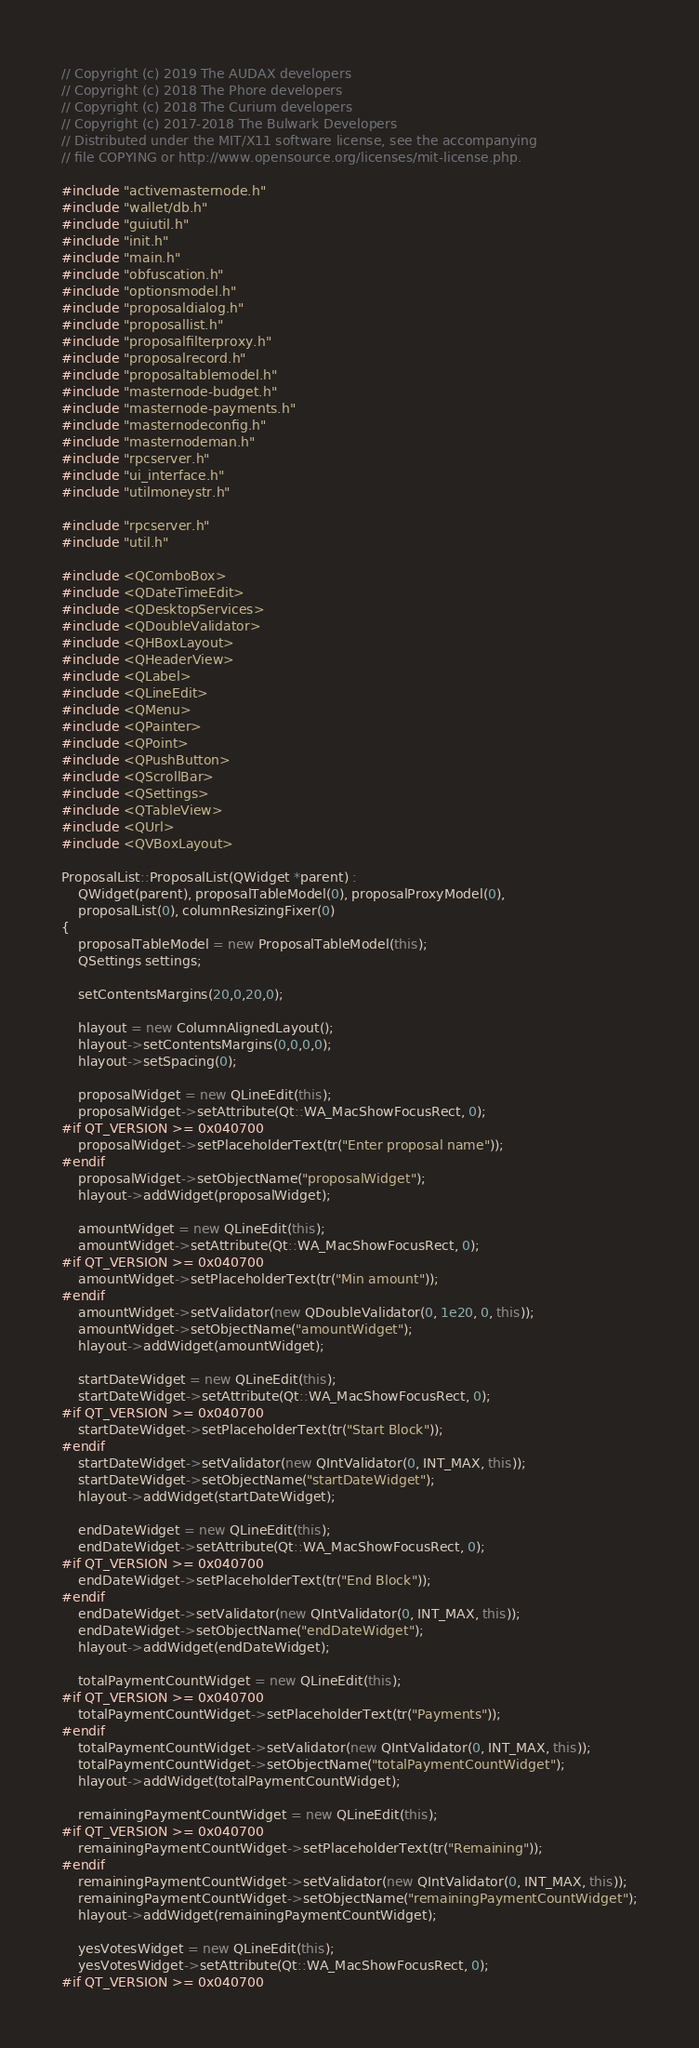<code> <loc_0><loc_0><loc_500><loc_500><_C++_>// Copyright (c) 2019 The AUDAX developers
// Copyright (c) 2018 The Phore developers
// Copyright (c) 2018 The Curium developers
// Copyright (c) 2017-2018 The Bulwark Developers
// Distributed under the MIT/X11 software license, see the accompanying
// file COPYING or http://www.opensource.org/licenses/mit-license.php.

#include "activemasternode.h"
#include "wallet/db.h"
#include "guiutil.h"
#include "init.h"
#include "main.h"
#include "obfuscation.h"
#include "optionsmodel.h"
#include "proposaldialog.h"
#include "proposallist.h"
#include "proposalfilterproxy.h"
#include "proposalrecord.h"
#include "proposaltablemodel.h"
#include "masternode-budget.h"
#include "masternode-payments.h"
#include "masternodeconfig.h"
#include "masternodeman.h"
#include "rpcserver.h"
#include "ui_interface.h"
#include "utilmoneystr.h"

#include "rpcserver.h"
#include "util.h"

#include <QComboBox>
#include <QDateTimeEdit>
#include <QDesktopServices>
#include <QDoubleValidator>
#include <QHBoxLayout>
#include <QHeaderView>
#include <QLabel>
#include <QLineEdit>
#include <QMenu>
#include <QPainter>
#include <QPoint>
#include <QPushButton>
#include <QScrollBar>
#include <QSettings>
#include <QTableView>
#include <QUrl>
#include <QVBoxLayout>

ProposalList::ProposalList(QWidget *parent) :
    QWidget(parent), proposalTableModel(0), proposalProxyModel(0),
    proposalList(0), columnResizingFixer(0)
{
    proposalTableModel = new ProposalTableModel(this);
    QSettings settings;

    setContentsMargins(20,0,20,0);

    hlayout = new ColumnAlignedLayout();
    hlayout->setContentsMargins(0,0,0,0);
    hlayout->setSpacing(0);

    proposalWidget = new QLineEdit(this);
    proposalWidget->setAttribute(Qt::WA_MacShowFocusRect, 0);
#if QT_VERSION >= 0x040700
    proposalWidget->setPlaceholderText(tr("Enter proposal name"));
#endif
    proposalWidget->setObjectName("proposalWidget");
    hlayout->addWidget(proposalWidget);

    amountWidget = new QLineEdit(this);
    amountWidget->setAttribute(Qt::WA_MacShowFocusRect, 0);
#if QT_VERSION >= 0x040700
    amountWidget->setPlaceholderText(tr("Min amount"));
#endif
    amountWidget->setValidator(new QDoubleValidator(0, 1e20, 0, this));
    amountWidget->setObjectName("amountWidget");
    hlayout->addWidget(amountWidget);

    startDateWidget = new QLineEdit(this);
    startDateWidget->setAttribute(Qt::WA_MacShowFocusRect, 0);
#if QT_VERSION >= 0x040700
    startDateWidget->setPlaceholderText(tr("Start Block"));
#endif
    startDateWidget->setValidator(new QIntValidator(0, INT_MAX, this));
    startDateWidget->setObjectName("startDateWidget");
    hlayout->addWidget(startDateWidget);

    endDateWidget = new QLineEdit(this);
    endDateWidget->setAttribute(Qt::WA_MacShowFocusRect, 0);
#if QT_VERSION >= 0x040700
    endDateWidget->setPlaceholderText(tr("End Block"));
#endif
    endDateWidget->setValidator(new QIntValidator(0, INT_MAX, this));
    endDateWidget->setObjectName("endDateWidget");
    hlayout->addWidget(endDateWidget);

    totalPaymentCountWidget = new QLineEdit(this);
#if QT_VERSION >= 0x040700
    totalPaymentCountWidget->setPlaceholderText(tr("Payments"));
#endif
    totalPaymentCountWidget->setValidator(new QIntValidator(0, INT_MAX, this));
    totalPaymentCountWidget->setObjectName("totalPaymentCountWidget");
    hlayout->addWidget(totalPaymentCountWidget);

    remainingPaymentCountWidget = new QLineEdit(this);
#if QT_VERSION >= 0x040700
    remainingPaymentCountWidget->setPlaceholderText(tr("Remaining"));
#endif
    remainingPaymentCountWidget->setValidator(new QIntValidator(0, INT_MAX, this));
    remainingPaymentCountWidget->setObjectName("remainingPaymentCountWidget");
    hlayout->addWidget(remainingPaymentCountWidget);

    yesVotesWidget = new QLineEdit(this);
    yesVotesWidget->setAttribute(Qt::WA_MacShowFocusRect, 0);
#if QT_VERSION >= 0x040700</code> 